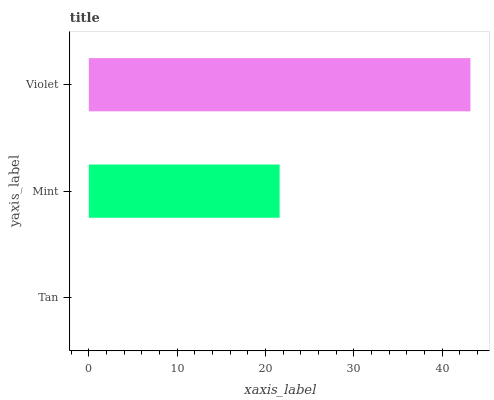Is Tan the minimum?
Answer yes or no. Yes. Is Violet the maximum?
Answer yes or no. Yes. Is Mint the minimum?
Answer yes or no. No. Is Mint the maximum?
Answer yes or no. No. Is Mint greater than Tan?
Answer yes or no. Yes. Is Tan less than Mint?
Answer yes or no. Yes. Is Tan greater than Mint?
Answer yes or no. No. Is Mint less than Tan?
Answer yes or no. No. Is Mint the high median?
Answer yes or no. Yes. Is Mint the low median?
Answer yes or no. Yes. Is Tan the high median?
Answer yes or no. No. Is Violet the low median?
Answer yes or no. No. 